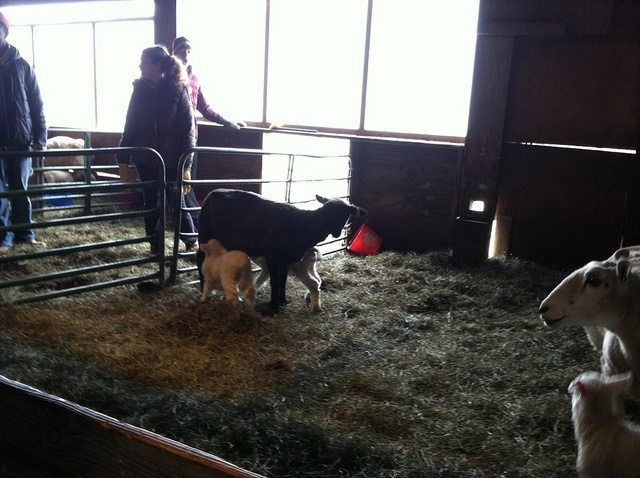Describe the objects in this image and their specific colors. I can see sheep in gray, black, white, and darkgray tones, people in gray, black, navy, purple, and white tones, people in gray, black, and navy tones, sheep in gray, black, darkgray, and lightgray tones, and sheep in gray, black, and darkgray tones in this image. 